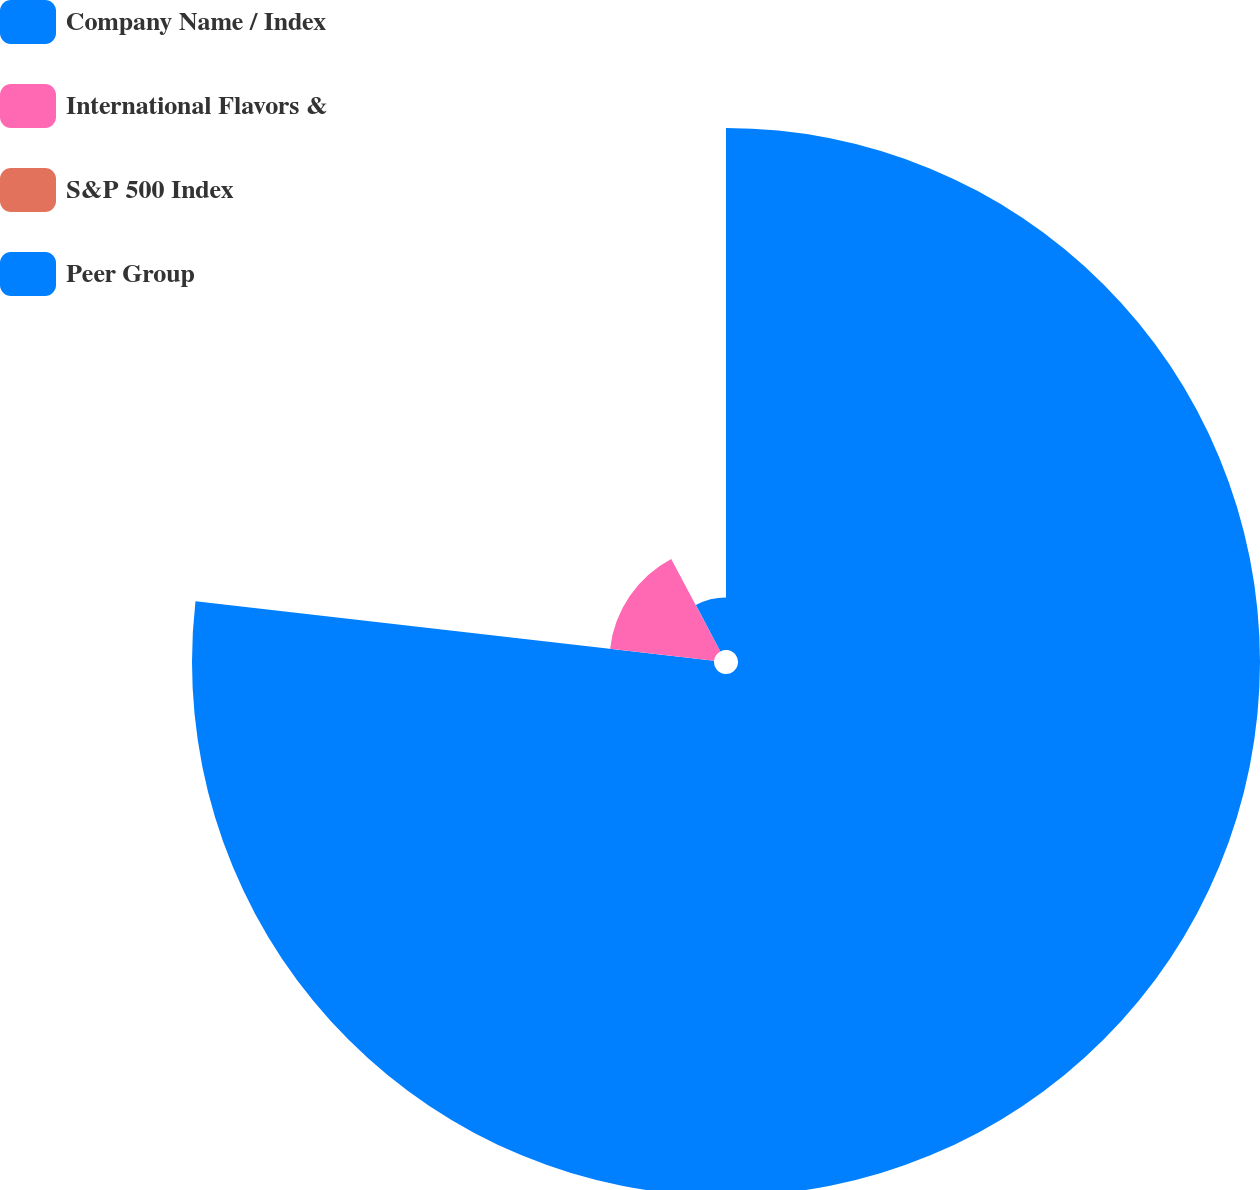Convert chart to OTSL. <chart><loc_0><loc_0><loc_500><loc_500><pie_chart><fcel>Company Name / Index<fcel>International Flavors &<fcel>S&P 500 Index<fcel>Peer Group<nl><fcel>76.81%<fcel>15.4%<fcel>0.05%<fcel>7.73%<nl></chart> 